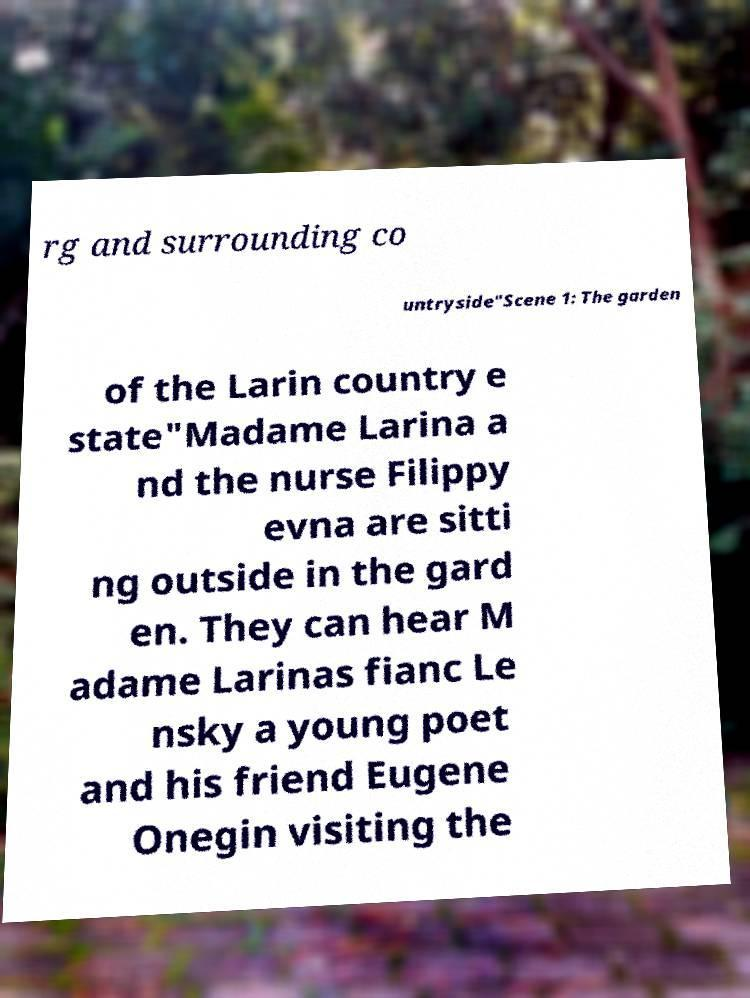Could you extract and type out the text from this image? rg and surrounding co untryside"Scene 1: The garden of the Larin country e state"Madame Larina a nd the nurse Filippy evna are sitti ng outside in the gard en. They can hear M adame Larinas fianc Le nsky a young poet and his friend Eugene Onegin visiting the 